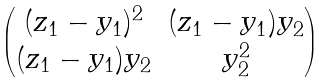Convert formula to latex. <formula><loc_0><loc_0><loc_500><loc_500>\begin{pmatrix} ( z _ { 1 } - y _ { 1 } ) ^ { 2 } & ( z _ { 1 } - y _ { 1 } ) y _ { 2 } \\ ( z _ { 1 } - y _ { 1 } ) y _ { 2 } & y _ { 2 } ^ { 2 } \end{pmatrix}</formula> 